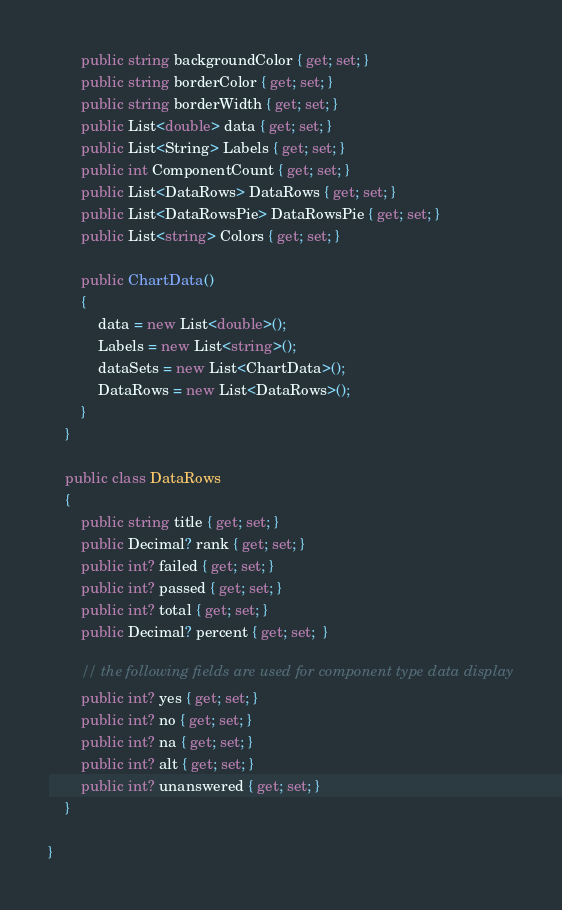Convert code to text. <code><loc_0><loc_0><loc_500><loc_500><_C#_>        public string backgroundColor { get; set; }
        public string borderColor { get; set; }
        public string borderWidth { get; set; }
        public List<double> data { get; set; }
        public List<String> Labels { get; set; }
        public int ComponentCount { get; set; }
        public List<DataRows> DataRows { get; set; }
        public List<DataRowsPie> DataRowsPie { get; set; }
        public List<string> Colors { get; set; }

        public ChartData()
        {
            data = new List<double>();
            Labels = new List<string>();
            dataSets = new List<ChartData>();
            DataRows = new List<DataRows>();
        }
    }

    public class DataRows
    {
        public string title { get; set; }
        public Decimal? rank { get; set; }
        public int? failed { get; set; }
        public int? passed { get; set; }
        public int? total { get; set; }
        public Decimal? percent { get; set;  }

        // the following fields are used for component type data display
        public int? yes { get; set; }
        public int? no { get; set; }
        public int? na { get; set; }
        public int? alt { get; set; }
        public int? unanswered { get; set; }
    }

}

</code> 